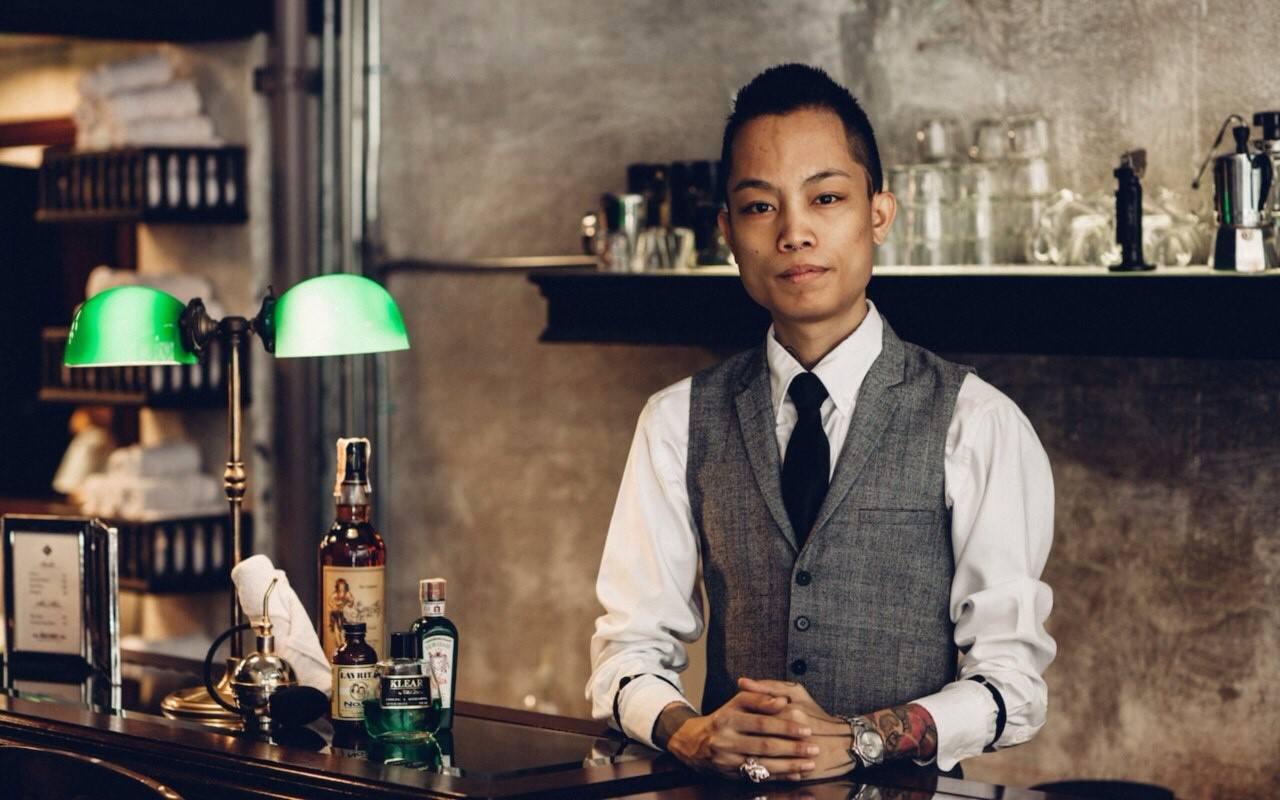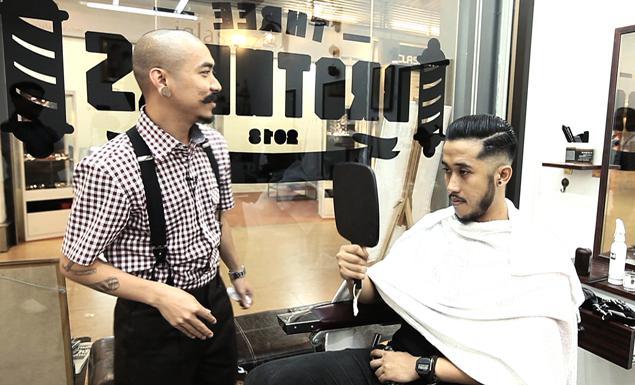The first image is the image on the left, the second image is the image on the right. Given the left and right images, does the statement "There is exactly one person wearing a vest." hold true? Answer yes or no. Yes. The first image is the image on the left, the second image is the image on the right. For the images shown, is this caption "There is a single man in a barbershop chair with at least one other man next to him with no sissors." true? Answer yes or no. Yes. 